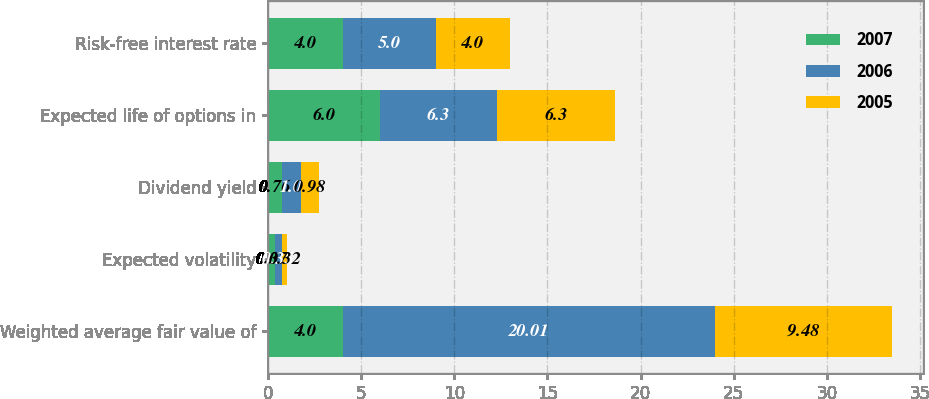Convert chart to OTSL. <chart><loc_0><loc_0><loc_500><loc_500><stacked_bar_chart><ecel><fcel>Weighted average fair value of<fcel>Expected volatility<fcel>Dividend yield<fcel>Expected life of options in<fcel>Risk-free interest rate<nl><fcel>2007<fcel>4<fcel>0.37<fcel>0.76<fcel>6<fcel>4<nl><fcel>2006<fcel>20.01<fcel>0.35<fcel>1<fcel>6.3<fcel>5<nl><fcel>2005<fcel>9.48<fcel>0.32<fcel>0.98<fcel>6.3<fcel>4<nl></chart> 